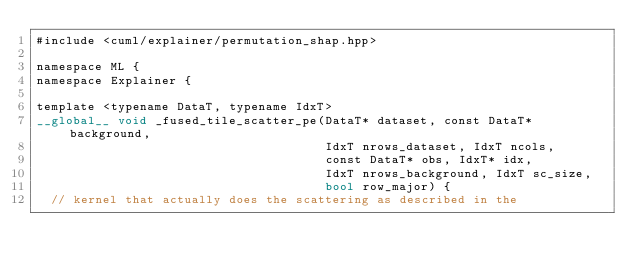Convert code to text. <code><loc_0><loc_0><loc_500><loc_500><_Cuda_>#include <cuml/explainer/permutation_shap.hpp>

namespace ML {
namespace Explainer {

template <typename DataT, typename IdxT>
__global__ void _fused_tile_scatter_pe(DataT* dataset, const DataT* background,
                                       IdxT nrows_dataset, IdxT ncols,
                                       const DataT* obs, IdxT* idx,
                                       IdxT nrows_background, IdxT sc_size,
                                       bool row_major) {
  // kernel that actually does the scattering as described in the</code> 